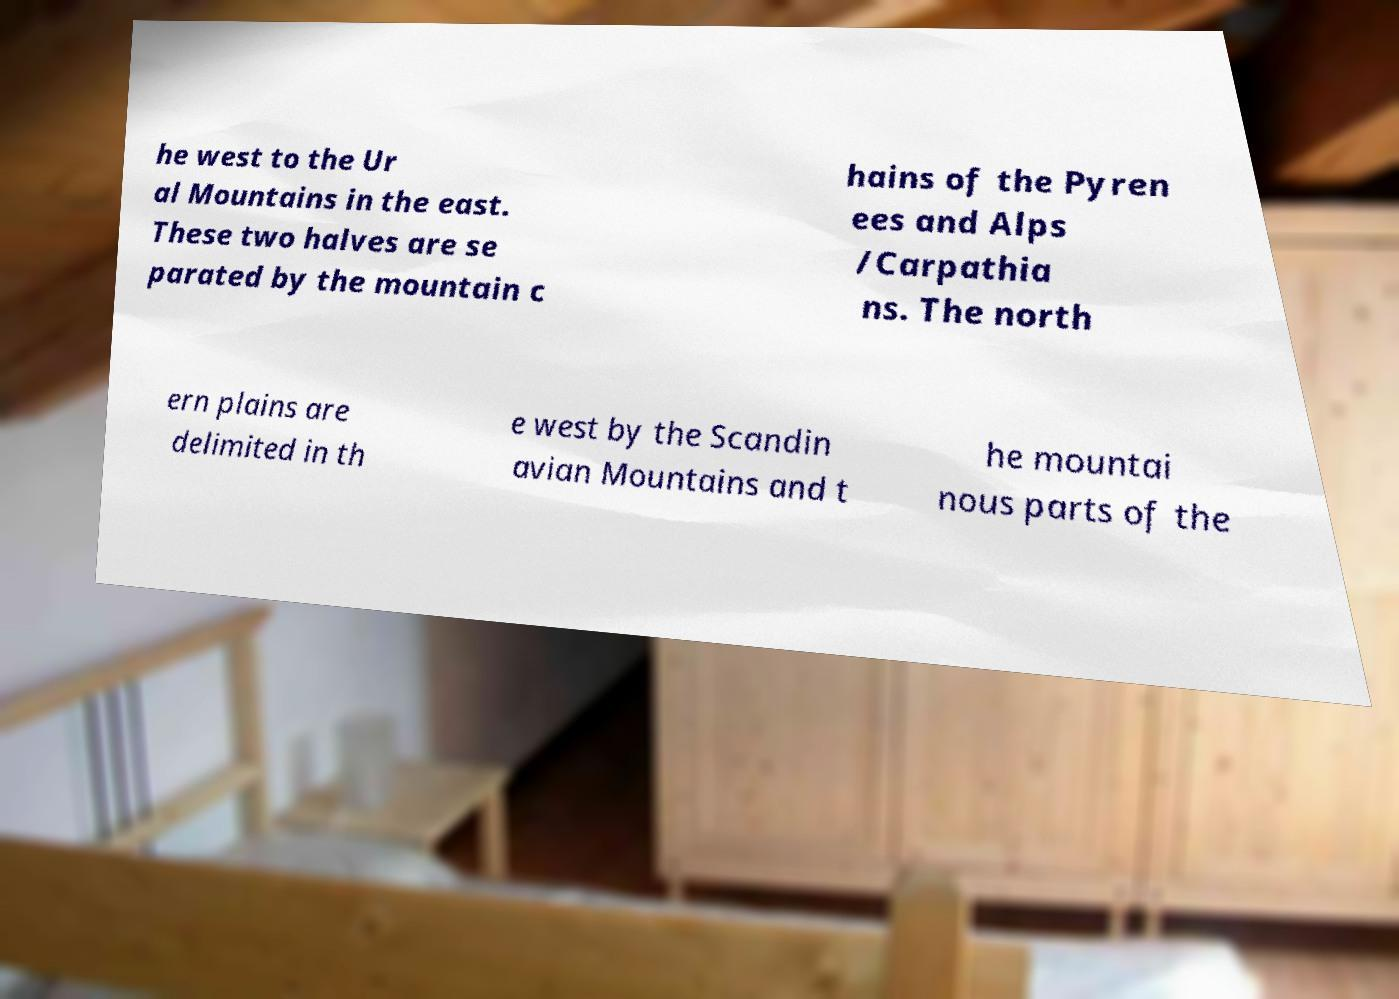Please read and relay the text visible in this image. What does it say? he west to the Ur al Mountains in the east. These two halves are se parated by the mountain c hains of the Pyren ees and Alps /Carpathia ns. The north ern plains are delimited in th e west by the Scandin avian Mountains and t he mountai nous parts of the 